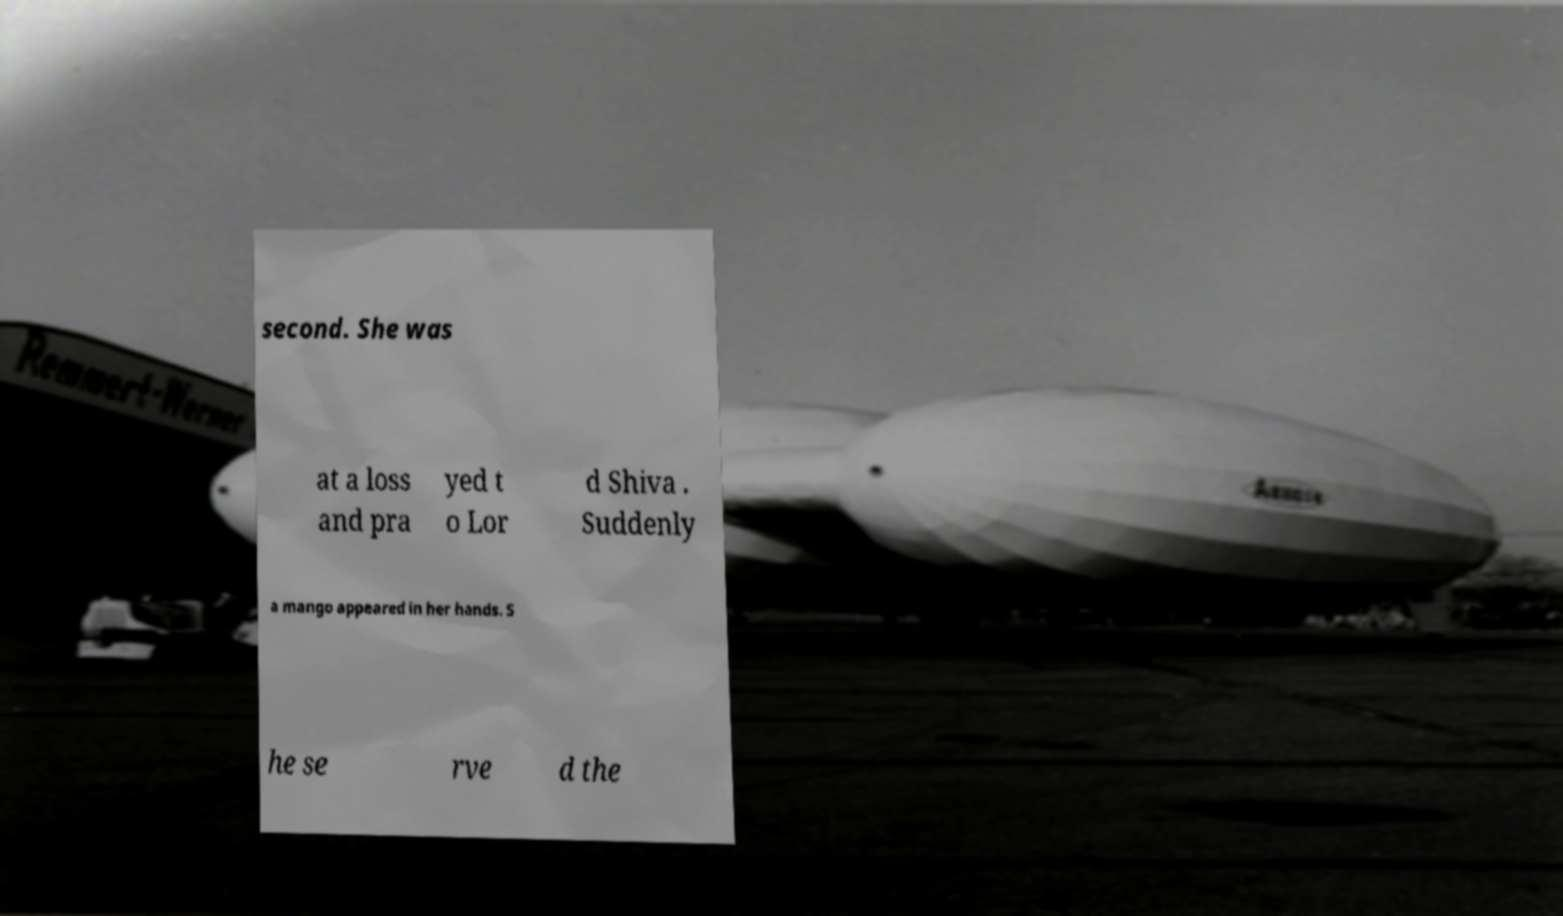What messages or text are displayed in this image? I need them in a readable, typed format. second. She was at a loss and pra yed t o Lor d Shiva . Suddenly a mango appeared in her hands. S he se rve d the 